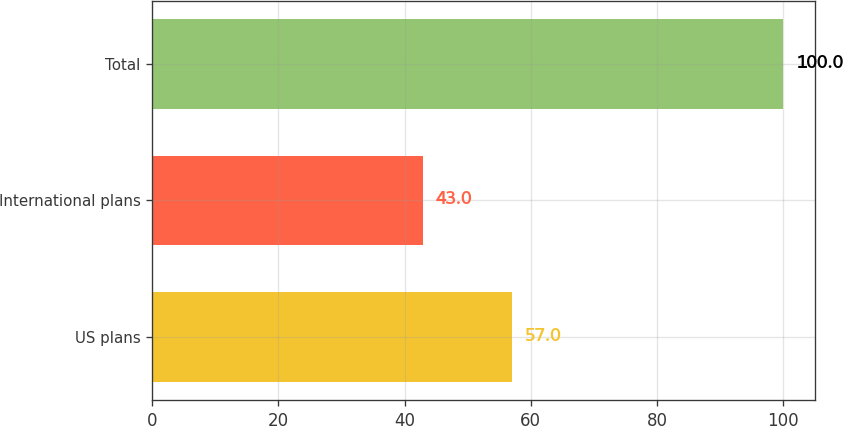Convert chart to OTSL. <chart><loc_0><loc_0><loc_500><loc_500><bar_chart><fcel>US plans<fcel>International plans<fcel>Total<nl><fcel>57<fcel>43<fcel>100<nl></chart> 